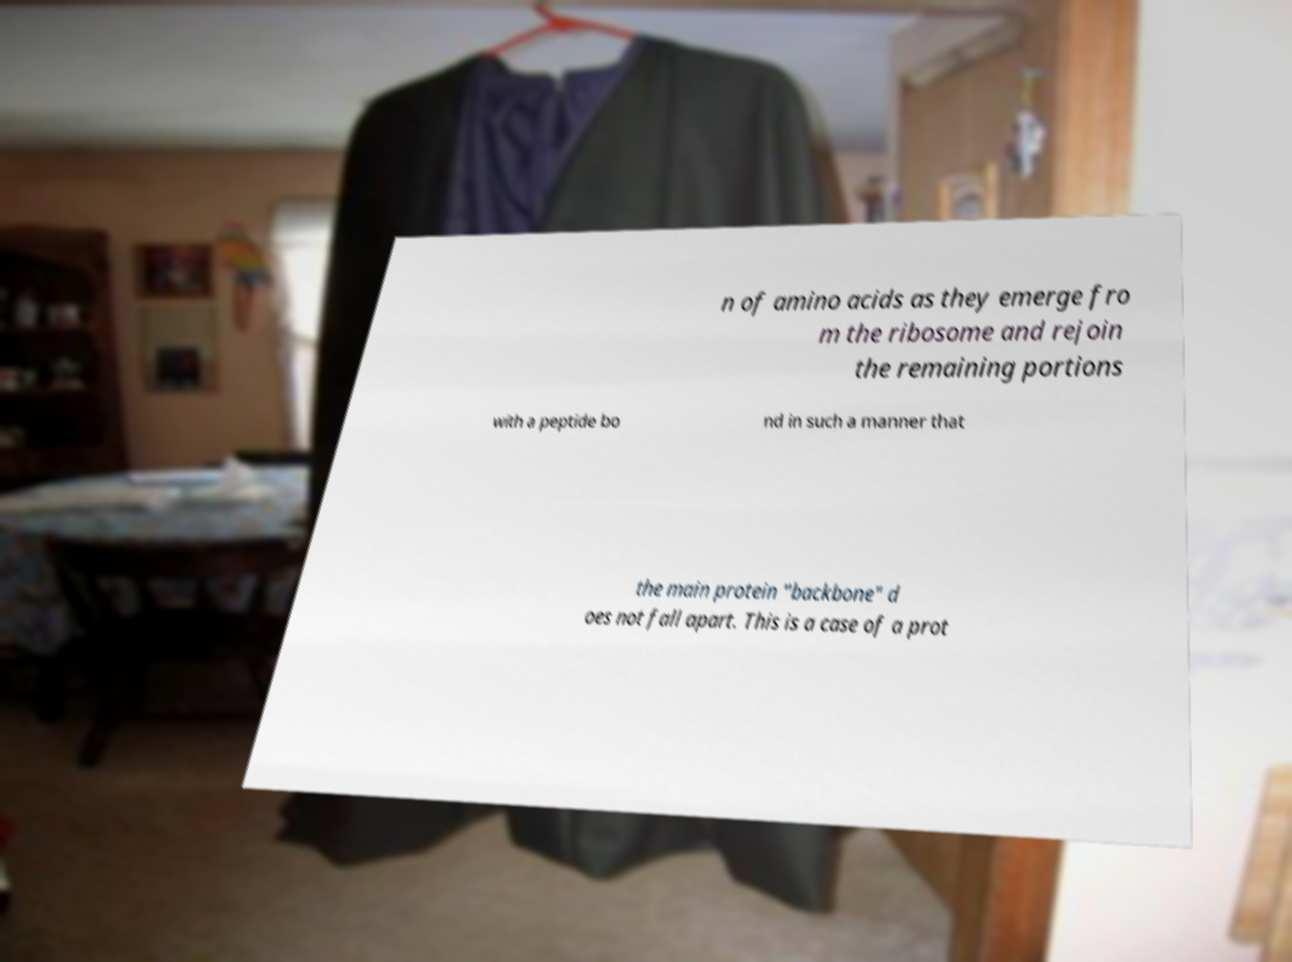Can you accurately transcribe the text from the provided image for me? n of amino acids as they emerge fro m the ribosome and rejoin the remaining portions with a peptide bo nd in such a manner that the main protein "backbone" d oes not fall apart. This is a case of a prot 